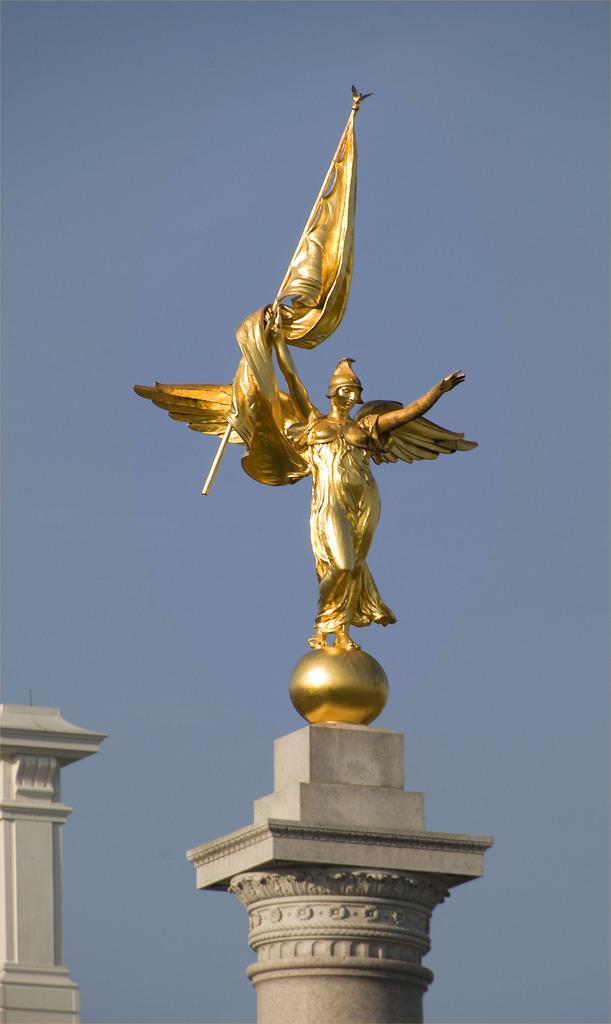Describe this image in one or two sentences. In this image, we can see a pillar with a statue. In the background, there is the sky. In the bottom left corner, there is another pillar.  